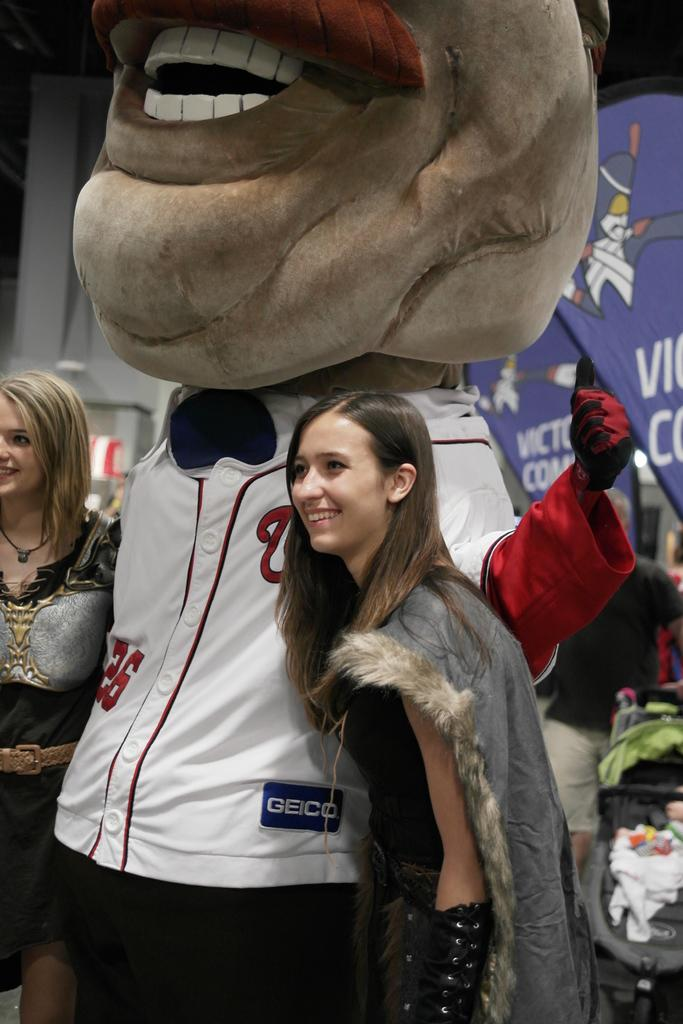<image>
Relay a brief, clear account of the picture shown. Woman posing next to a mascot wearing a jersey that says GEICO on it. 